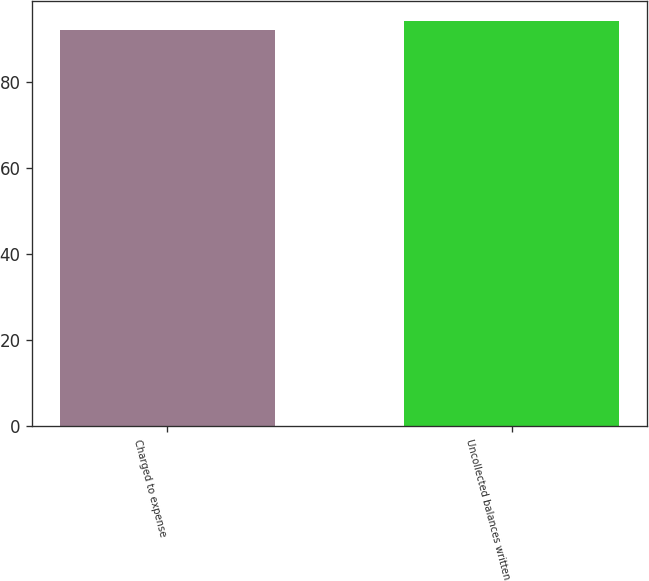Convert chart. <chart><loc_0><loc_0><loc_500><loc_500><bar_chart><fcel>Charged to expense<fcel>Uncollected balances written<nl><fcel>92<fcel>94<nl></chart> 